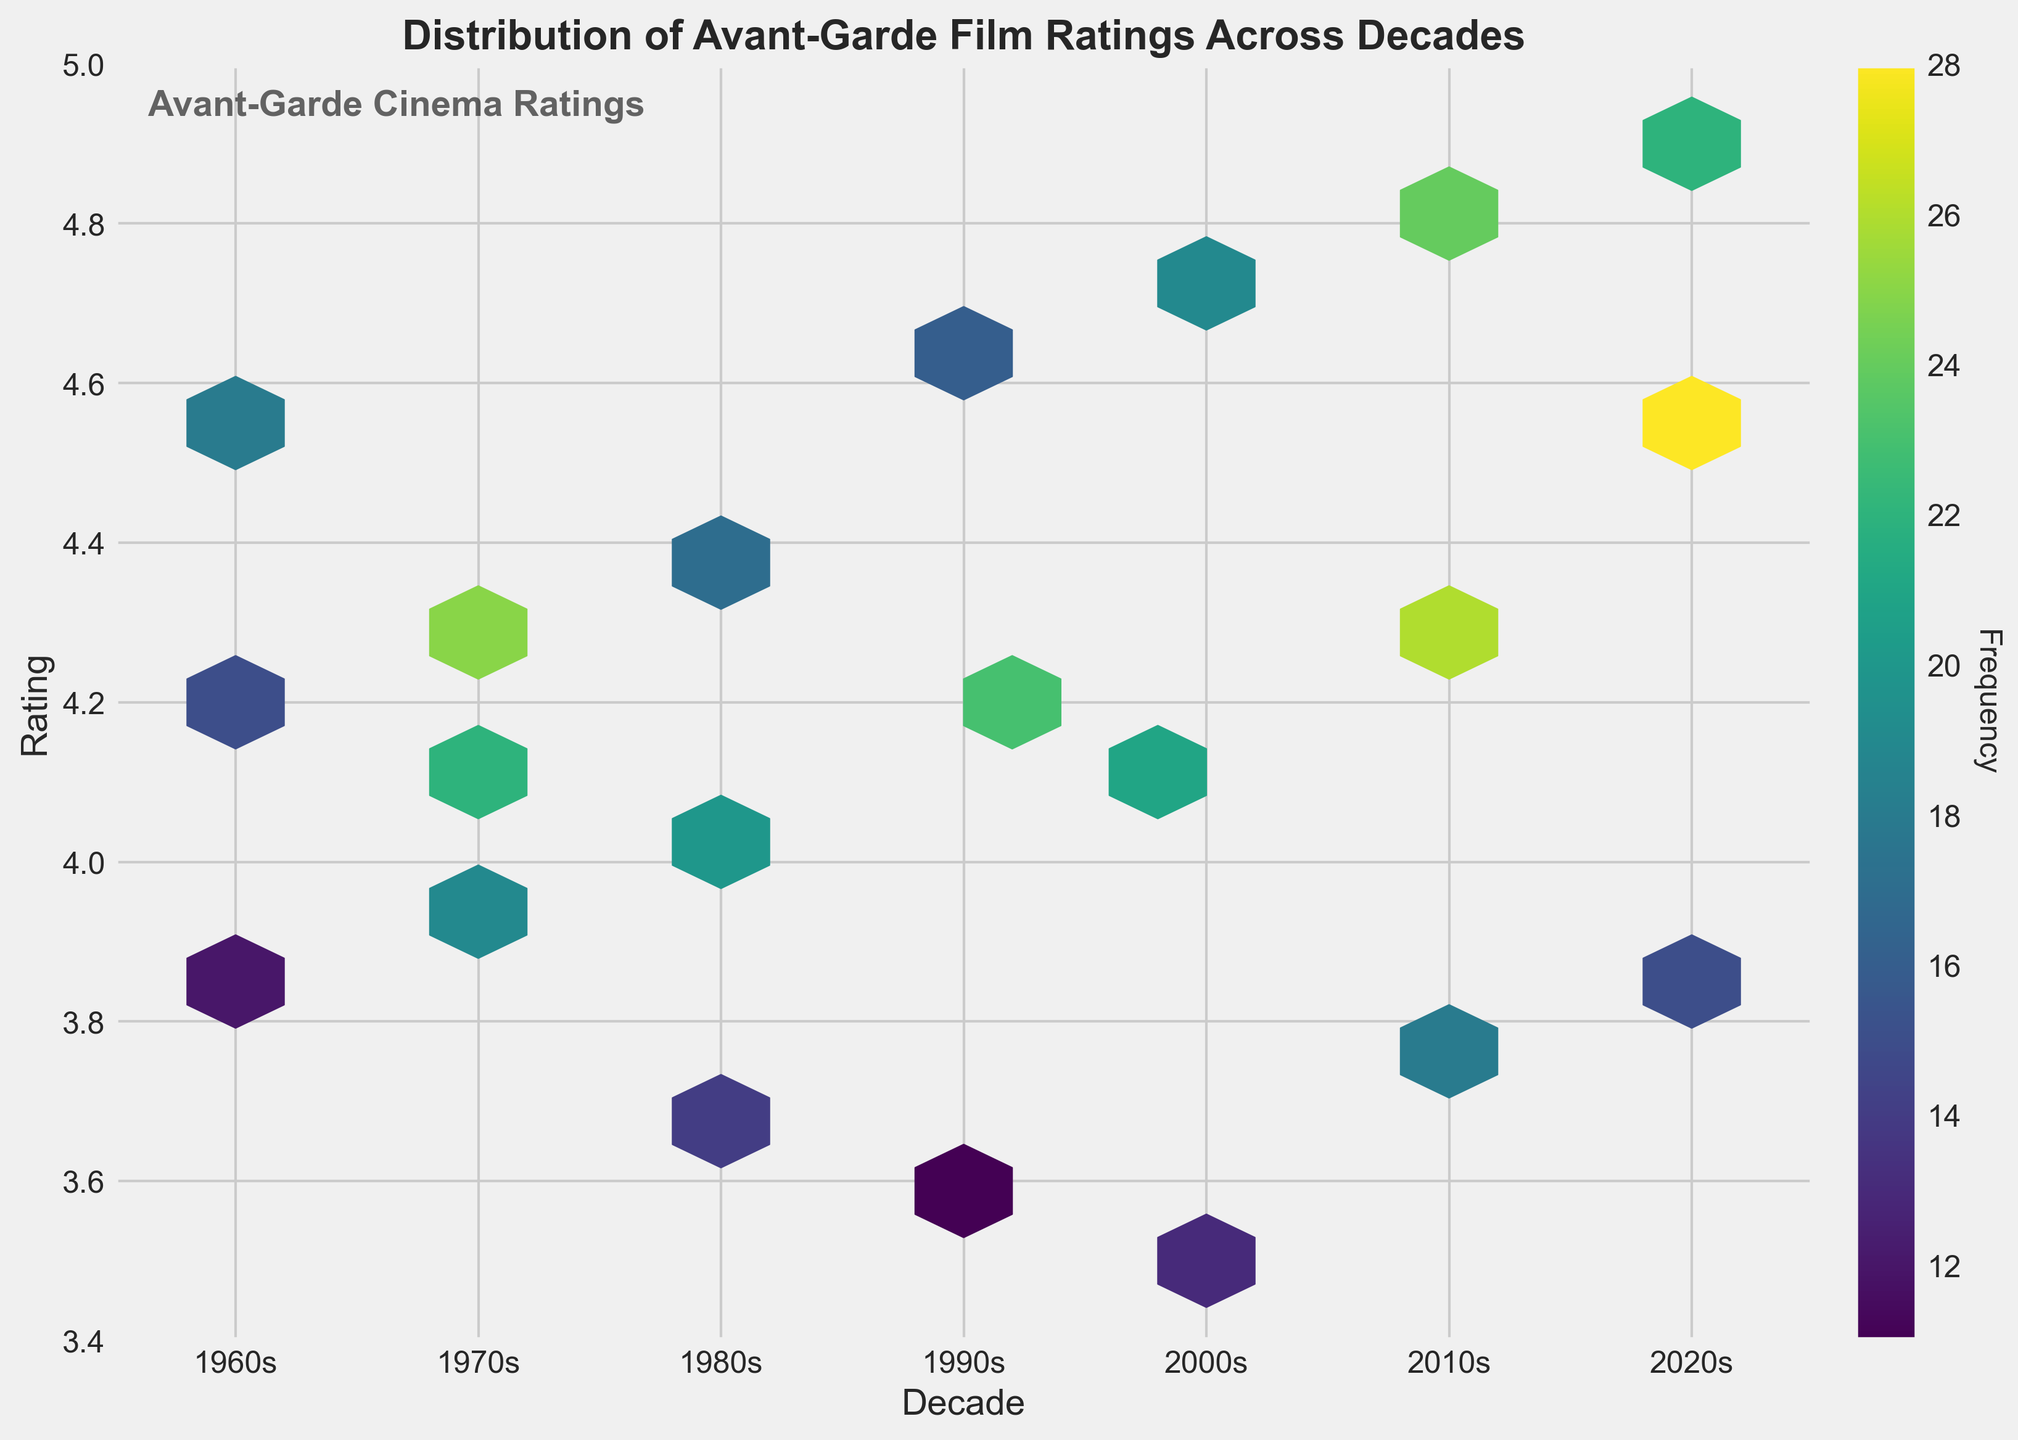What is the title of the plot? The title is usually prominently displayed at the top of the plot. In this case, the title is "Distribution of Avant-Garde Film Ratings Across Decades."
Answer: Distribution of Avant-Garde Film Ratings Across Decades What is represented by the x-axis? The x-axis in the plot generally indicates the variable being measured over time. Here, it is marked with decades starting from the 1960s to the 2020s, indicating that it represents different decades.
Answer: Decade What is represented by the y-axis? The y-axis in this plot is labeled with numerical values that align with typical film ratings (from 3.4 to 5.0). Thus, it represents the film ratings.
Answer: Rating Which decade has the highest frequency of film ratings? To find this, we look at the color density, with darker colors indicating higher frequencies. The 2020s have the darkest hexagons, implying the highest frequency.
Answer: 2020s Which decade has the highest average film rating? We can look at the density of hexagons around the higher rating values. The 2020s have dark hexagons around 4.5 and above, suggesting the highest average rating.
Answer: 2020s How does the film rating distribution change over the decades? The distribution is shown by the spread of hexagons along the y-axis for each decade on the x-axis. The ratings seem to range from 3.5 to about 4.9 over the decades, with the trend of higher ratings becoming more frequent in later decades.
Answer: Ratings trend upwards over time Which decade shows the widest range of film ratings? The widest range can be observed by the spread of the hexagons along the y-axis within each decade. The 2000s and 2010s show a diverse spread from around 3.5 to nearly 5.0.
Answer: 2000s and 2010s What's the most common rating for films in the 2010s? The most common rating can be identified by the darkest hexagon within that decade, located around a rating of 4.3.
Answer: 4.3 How do the frequencies of film ratings in the 1960s compare to the 1980s? By comparing the color intensity of hexagons between the two decades, we see that the 1960s have fewer ratings around the mid-range values compared to the 1980s.
Answer: 1980s ratings are more frequent Do any decades exhibit a clustering of extremely high ratings (above 4.6)? We can identify clustering by the concentration of hexagons in the upper range of the y-axis. The 2020s show clustering of ratings around 4.7 and above.
Answer: Yes, in the 2020s 